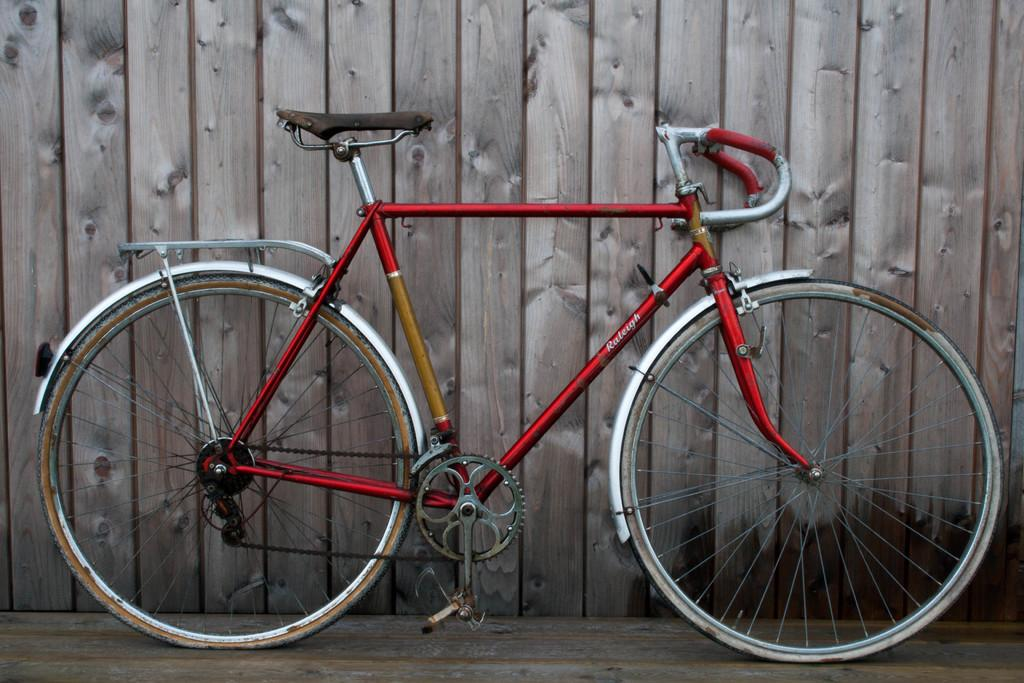What object is placed on the floor in the image? There is a bicycle on the floor in the image. What can be seen in the background of the image? There is a wall made up of wooden planks in the background of the image. What type of polish is being applied to the bicycle in the image? There is no polish being applied to the bicycle in the image; it is simply placed on the floor. 